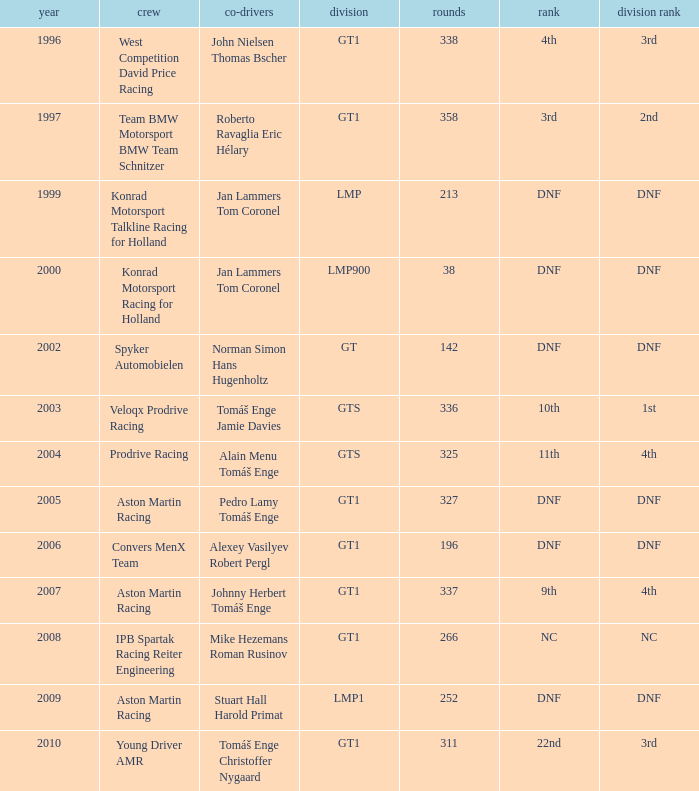Which position finished 3rd in class and completed less than 338 laps? 22nd. 